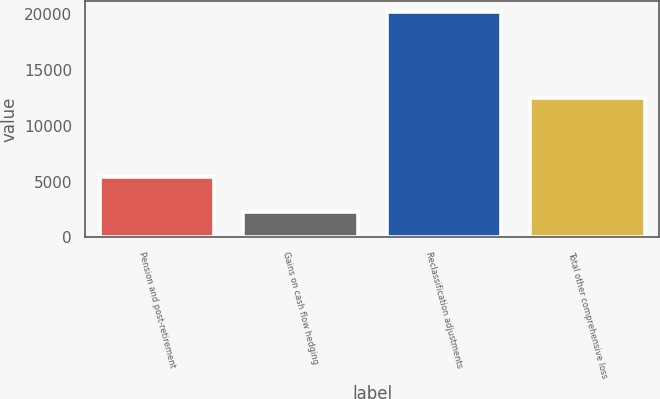Convert chart. <chart><loc_0><loc_0><loc_500><loc_500><bar_chart><fcel>Pension and post-retirement<fcel>Gains on cash flow hedging<fcel>Reclassification adjustments<fcel>Total other comprehensive loss<nl><fcel>5399<fcel>2259<fcel>20157<fcel>12499<nl></chart> 